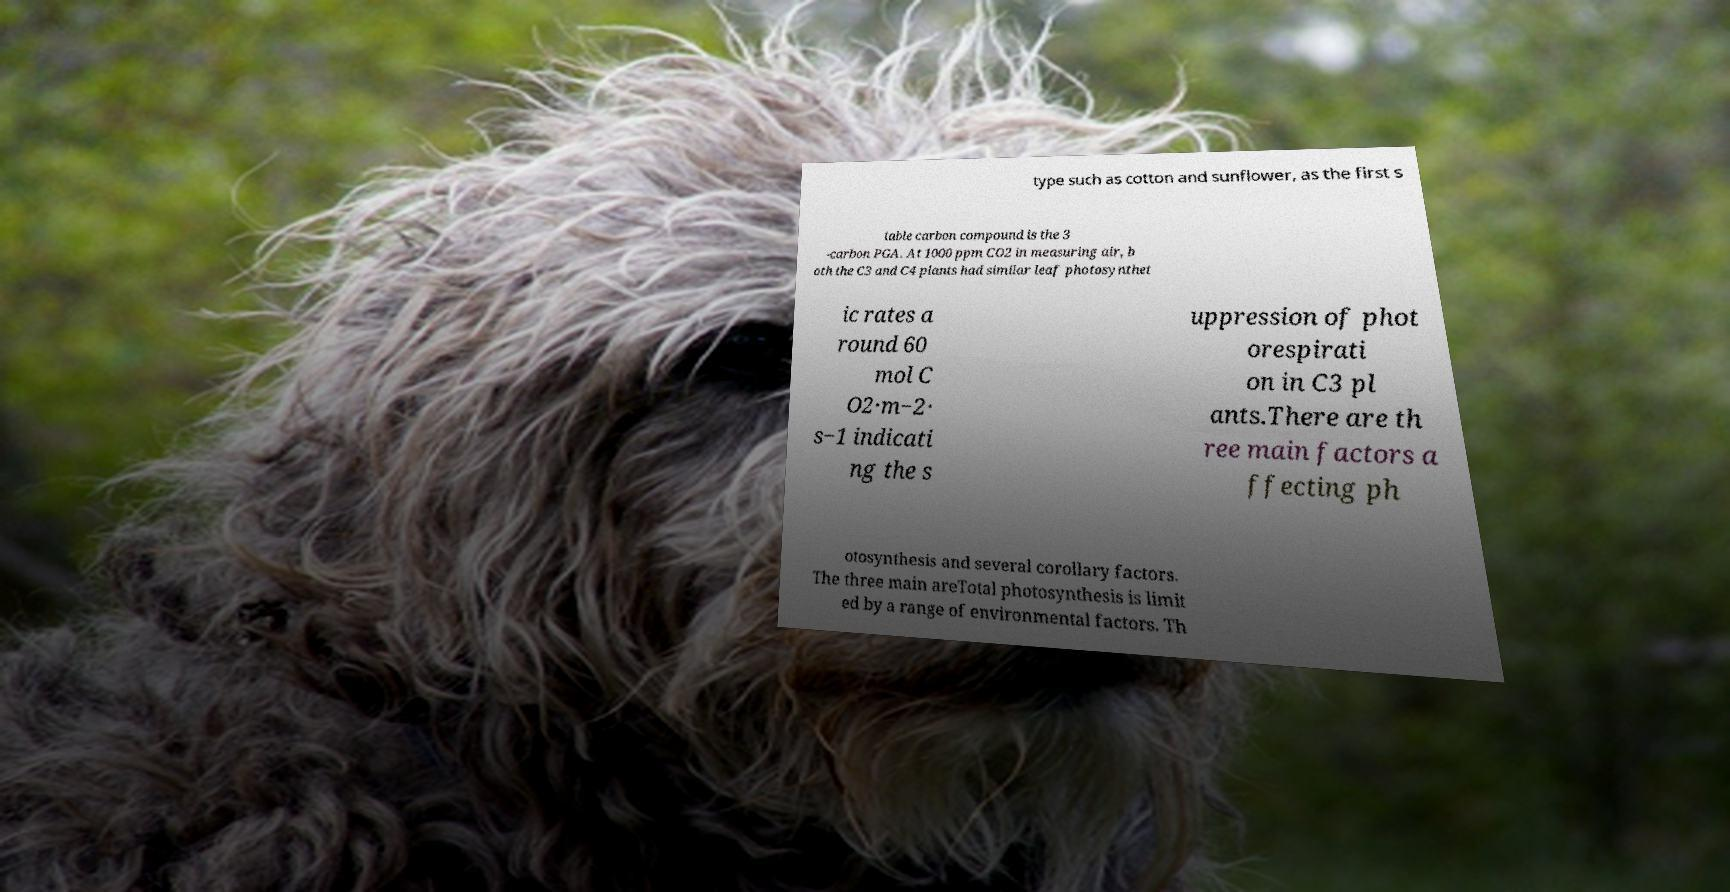Can you read and provide the text displayed in the image?This photo seems to have some interesting text. Can you extract and type it out for me? type such as cotton and sunflower, as the first s table carbon compound is the 3 -carbon PGA. At 1000 ppm CO2 in measuring air, b oth the C3 and C4 plants had similar leaf photosynthet ic rates a round 60 mol C O2·m−2· s−1 indicati ng the s uppression of phot orespirati on in C3 pl ants.There are th ree main factors a ffecting ph otosynthesis and several corollary factors. The three main areTotal photosynthesis is limit ed by a range of environmental factors. Th 